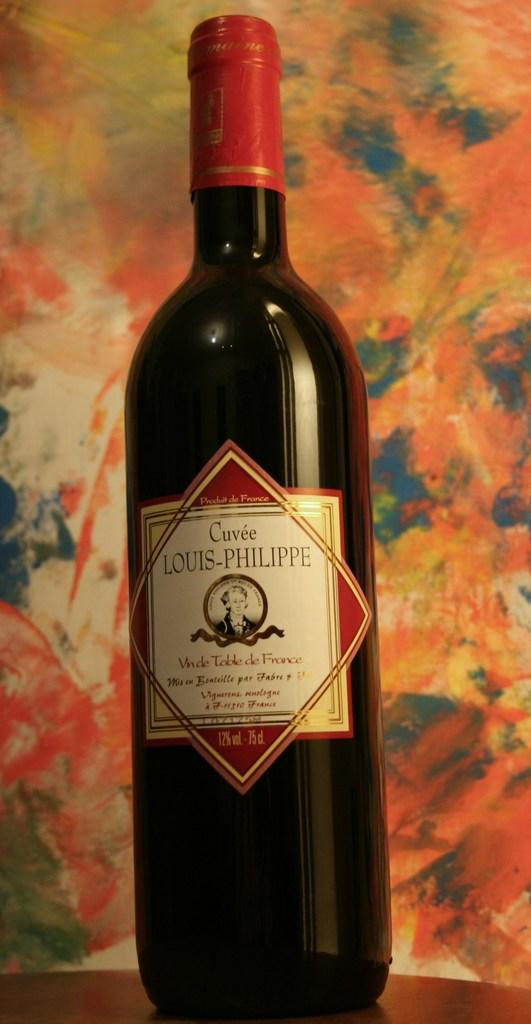<image>
Summarize the visual content of the image. According to the label, a bottle of wine has 12% alcohol per volume. 